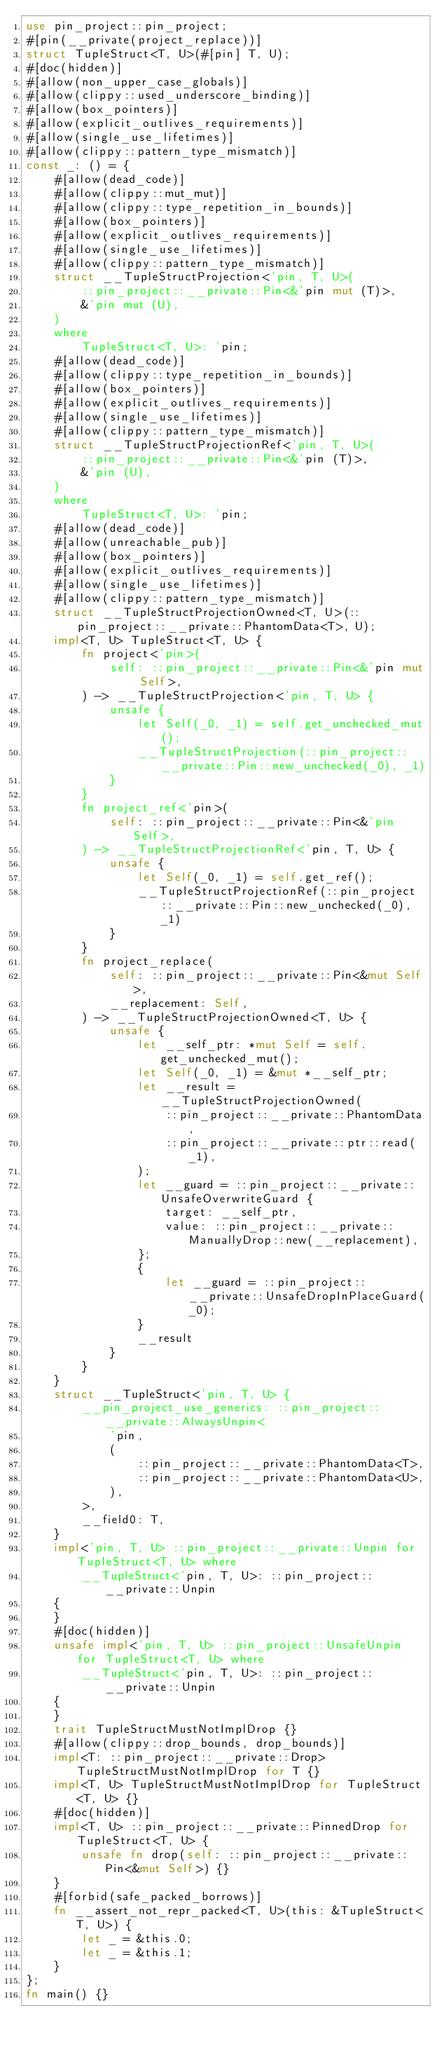Convert code to text. <code><loc_0><loc_0><loc_500><loc_500><_Rust_>use pin_project::pin_project;
#[pin(__private(project_replace))]
struct TupleStruct<T, U>(#[pin] T, U);
#[doc(hidden)]
#[allow(non_upper_case_globals)]
#[allow(clippy::used_underscore_binding)]
#[allow(box_pointers)]
#[allow(explicit_outlives_requirements)]
#[allow(single_use_lifetimes)]
#[allow(clippy::pattern_type_mismatch)]
const _: () = {
    #[allow(dead_code)]
    #[allow(clippy::mut_mut)]
    #[allow(clippy::type_repetition_in_bounds)]
    #[allow(box_pointers)]
    #[allow(explicit_outlives_requirements)]
    #[allow(single_use_lifetimes)]
    #[allow(clippy::pattern_type_mismatch)]
    struct __TupleStructProjection<'pin, T, U>(
        ::pin_project::__private::Pin<&'pin mut (T)>,
        &'pin mut (U),
    )
    where
        TupleStruct<T, U>: 'pin;
    #[allow(dead_code)]
    #[allow(clippy::type_repetition_in_bounds)]
    #[allow(box_pointers)]
    #[allow(explicit_outlives_requirements)]
    #[allow(single_use_lifetimes)]
    #[allow(clippy::pattern_type_mismatch)]
    struct __TupleStructProjectionRef<'pin, T, U>(
        ::pin_project::__private::Pin<&'pin (T)>,
        &'pin (U),
    )
    where
        TupleStruct<T, U>: 'pin;
    #[allow(dead_code)]
    #[allow(unreachable_pub)]
    #[allow(box_pointers)]
    #[allow(explicit_outlives_requirements)]
    #[allow(single_use_lifetimes)]
    #[allow(clippy::pattern_type_mismatch)]
    struct __TupleStructProjectionOwned<T, U>(::pin_project::__private::PhantomData<T>, U);
    impl<T, U> TupleStruct<T, U> {
        fn project<'pin>(
            self: ::pin_project::__private::Pin<&'pin mut Self>,
        ) -> __TupleStructProjection<'pin, T, U> {
            unsafe {
                let Self(_0, _1) = self.get_unchecked_mut();
                __TupleStructProjection(::pin_project::__private::Pin::new_unchecked(_0), _1)
            }
        }
        fn project_ref<'pin>(
            self: ::pin_project::__private::Pin<&'pin Self>,
        ) -> __TupleStructProjectionRef<'pin, T, U> {
            unsafe {
                let Self(_0, _1) = self.get_ref();
                __TupleStructProjectionRef(::pin_project::__private::Pin::new_unchecked(_0), _1)
            }
        }
        fn project_replace(
            self: ::pin_project::__private::Pin<&mut Self>,
            __replacement: Self,
        ) -> __TupleStructProjectionOwned<T, U> {
            unsafe {
                let __self_ptr: *mut Self = self.get_unchecked_mut();
                let Self(_0, _1) = &mut *__self_ptr;
                let __result = __TupleStructProjectionOwned(
                    ::pin_project::__private::PhantomData,
                    ::pin_project::__private::ptr::read(_1),
                );
                let __guard = ::pin_project::__private::UnsafeOverwriteGuard {
                    target: __self_ptr,
                    value: ::pin_project::__private::ManuallyDrop::new(__replacement),
                };
                {
                    let __guard = ::pin_project::__private::UnsafeDropInPlaceGuard(_0);
                }
                __result
            }
        }
    }
    struct __TupleStruct<'pin, T, U> {
        __pin_project_use_generics: ::pin_project::__private::AlwaysUnpin<
            'pin,
            (
                ::pin_project::__private::PhantomData<T>,
                ::pin_project::__private::PhantomData<U>,
            ),
        >,
        __field0: T,
    }
    impl<'pin, T, U> ::pin_project::__private::Unpin for TupleStruct<T, U> where
        __TupleStruct<'pin, T, U>: ::pin_project::__private::Unpin
    {
    }
    #[doc(hidden)]
    unsafe impl<'pin, T, U> ::pin_project::UnsafeUnpin for TupleStruct<T, U> where
        __TupleStruct<'pin, T, U>: ::pin_project::__private::Unpin
    {
    }
    trait TupleStructMustNotImplDrop {}
    #[allow(clippy::drop_bounds, drop_bounds)]
    impl<T: ::pin_project::__private::Drop> TupleStructMustNotImplDrop for T {}
    impl<T, U> TupleStructMustNotImplDrop for TupleStruct<T, U> {}
    #[doc(hidden)]
    impl<T, U> ::pin_project::__private::PinnedDrop for TupleStruct<T, U> {
        unsafe fn drop(self: ::pin_project::__private::Pin<&mut Self>) {}
    }
    #[forbid(safe_packed_borrows)]
    fn __assert_not_repr_packed<T, U>(this: &TupleStruct<T, U>) {
        let _ = &this.0;
        let _ = &this.1;
    }
};
fn main() {}
</code> 